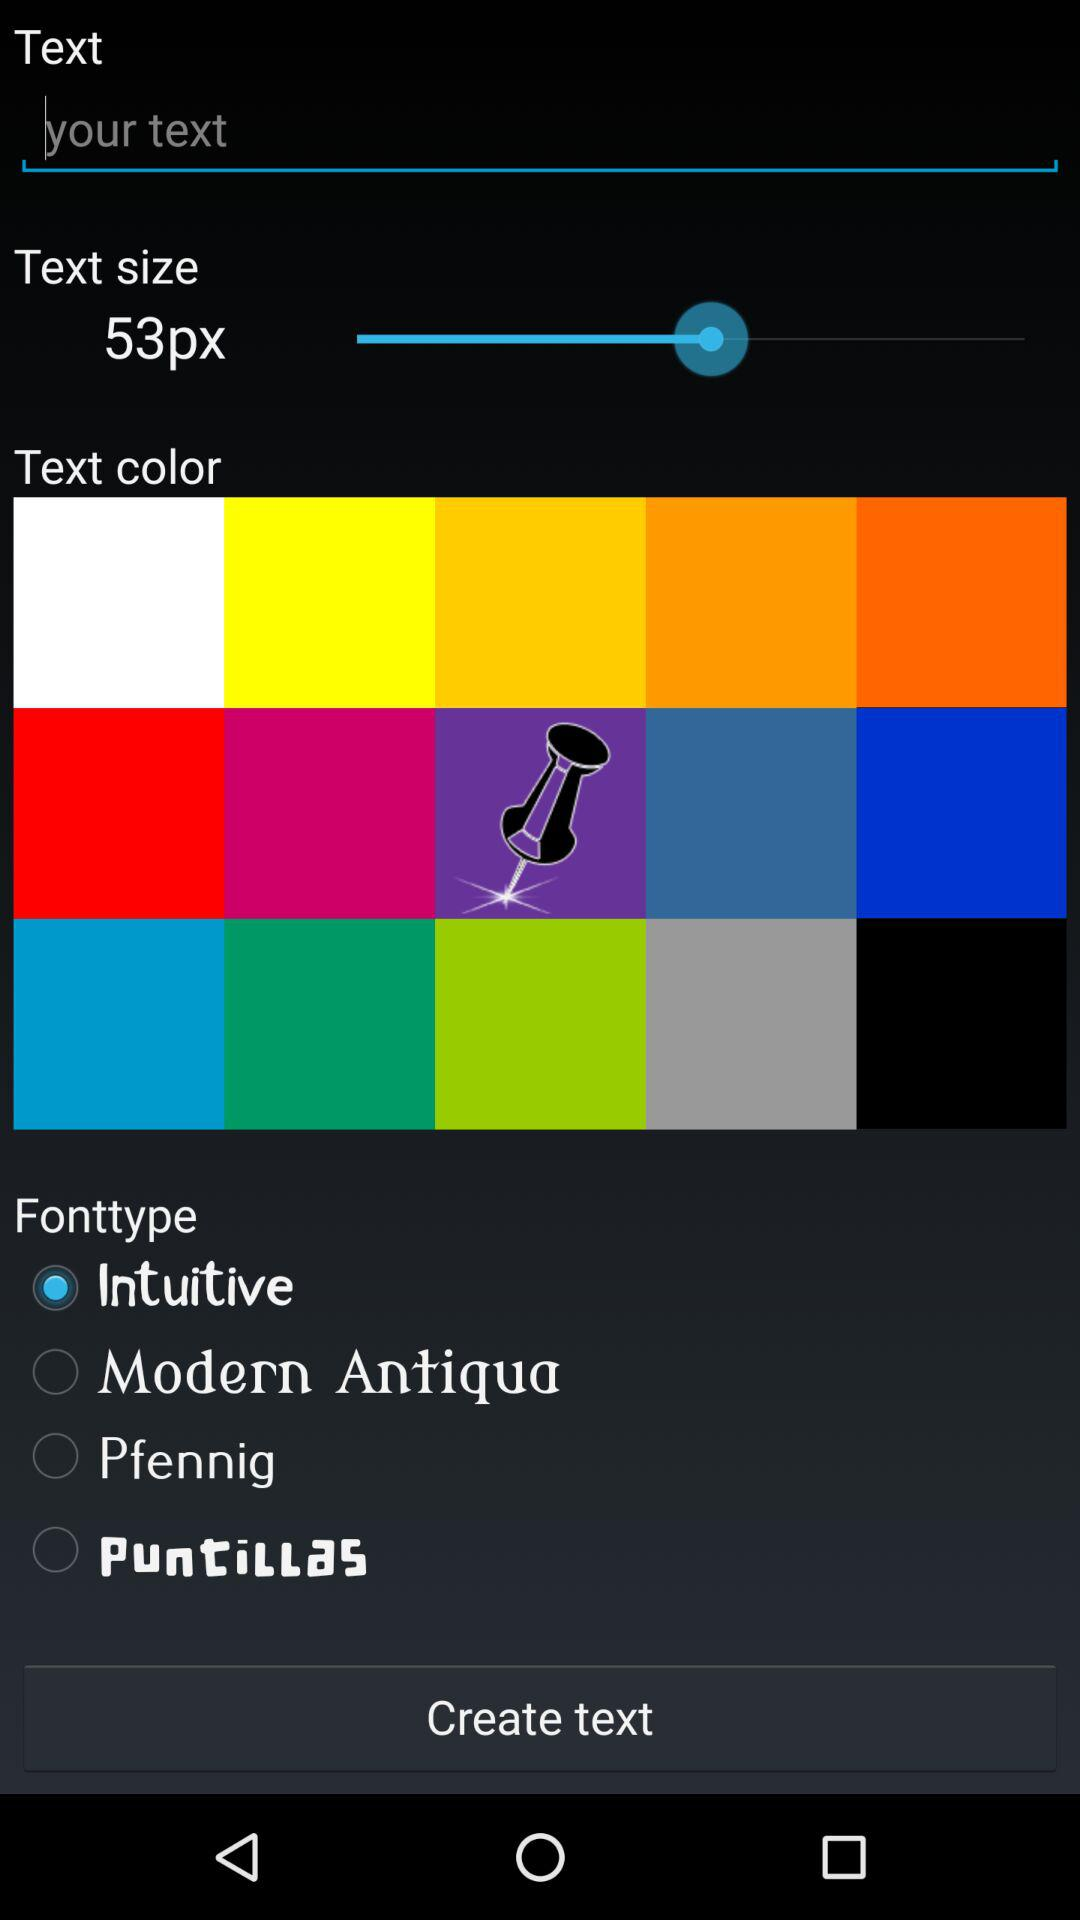Which are the different font type options? The different font type options are "Intuitive", "Modern Antiqua", "Pfennig" and "Puntillas". 